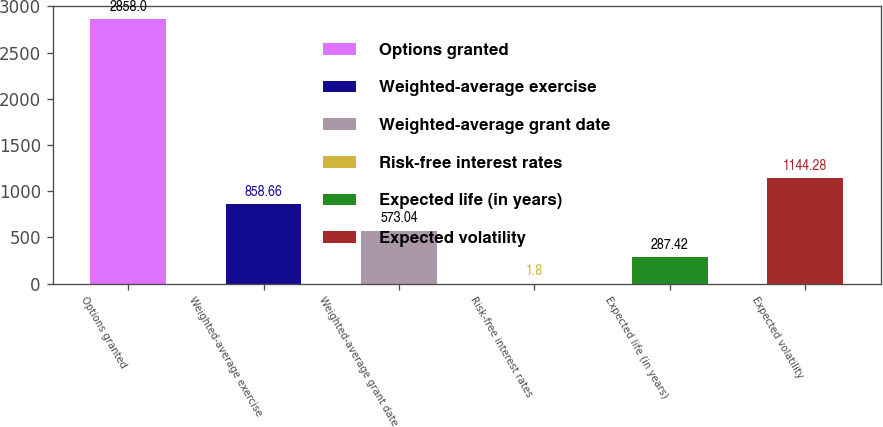Convert chart. <chart><loc_0><loc_0><loc_500><loc_500><bar_chart><fcel>Options granted<fcel>Weighted-average exercise<fcel>Weighted-average grant date<fcel>Risk-free interest rates<fcel>Expected life (in years)<fcel>Expected volatility<nl><fcel>2858<fcel>858.66<fcel>573.04<fcel>1.8<fcel>287.42<fcel>1144.28<nl></chart> 